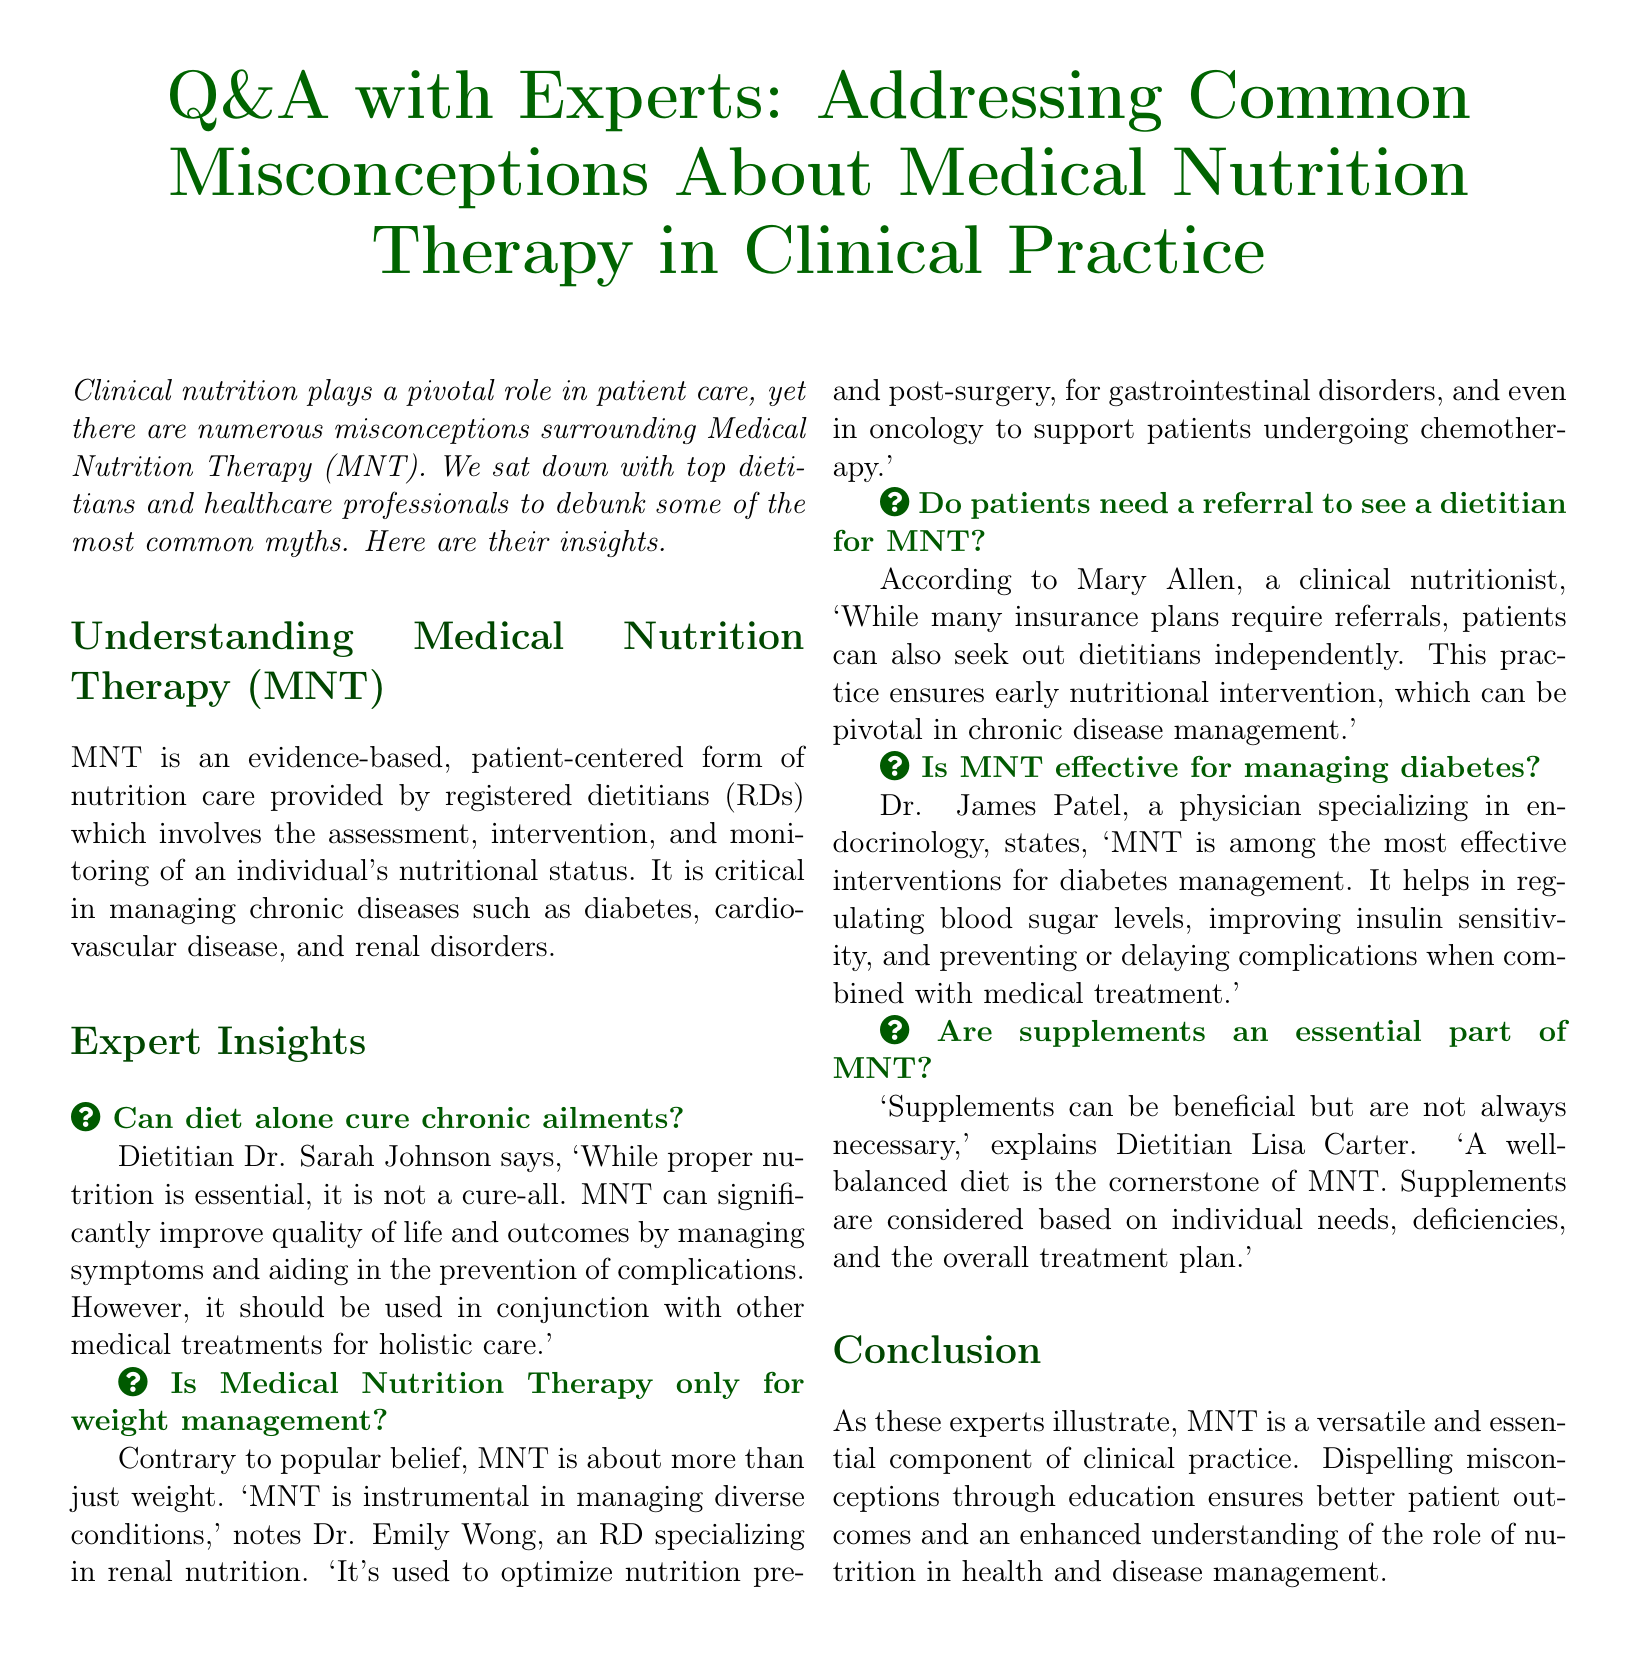What is MNT? MNT is defined in the document as an evidence-based, patient-centered form of nutrition care provided by registered dietitians.
Answer: An evidence-based, patient-centered form of nutrition care Who specializes in renal nutrition? The document mentions Dr. Emily Wong as an RD specializing in renal nutrition.
Answer: Dr. Emily Wong Is a referral required to see a dietitian? The document states that while many insurance plans require referrals, patients can also seek out dietitians independently.
Answer: No What is MNT effective for? The document notes that MNT is among the most effective interventions for diabetes management.
Answer: Diabetes management What is the cornerstone of MNT? The cornerstone of MNT, as indicated in the document, is a well-balanced diet.
Answer: A well-balanced diet How does MNT help with chronic diseases? The document illustrates that MNT can significantly improve quality of life and outcomes by managing symptoms and aiding in the prevention of complications.
Answer: Managing symptoms and aiding prevention of complications What is the role of supplements in MNT? According to the document, supplements can be beneficial but are not always necessary, and are based on individual needs.
Answer: Not always necessary What is the purpose of this document? The document aims to debunk common myths and misconceptions surrounding Medical Nutrition Therapy in clinical practice.
Answer: Debunking myths and misconceptions 